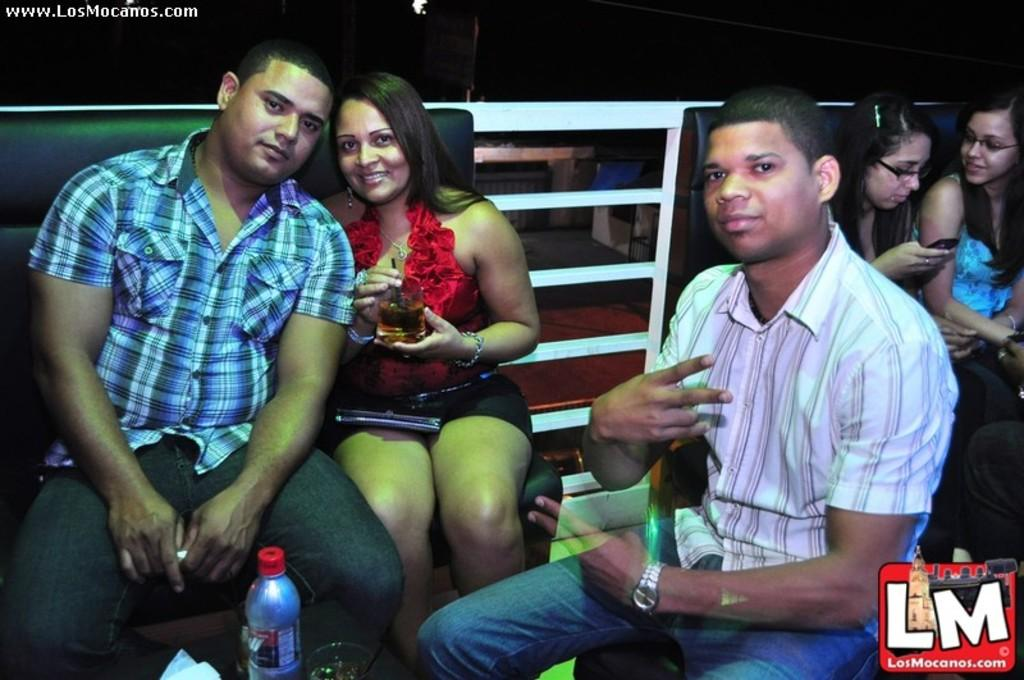How many people are present in the image? There are three people in the image. What are the people doing in the image? The people are sitting and drinking wine. What type of glasses are visible in the image? There are wine glasses in the image. What can be seen in the background of the image? There is a wall in the background of the image. What type of animal can be seen playing a record in the image? There is no animal or record present in the image. What musical instrument is being played by the people in the image? The provided facts do not mention any musical instruments being played by the people in the image. 